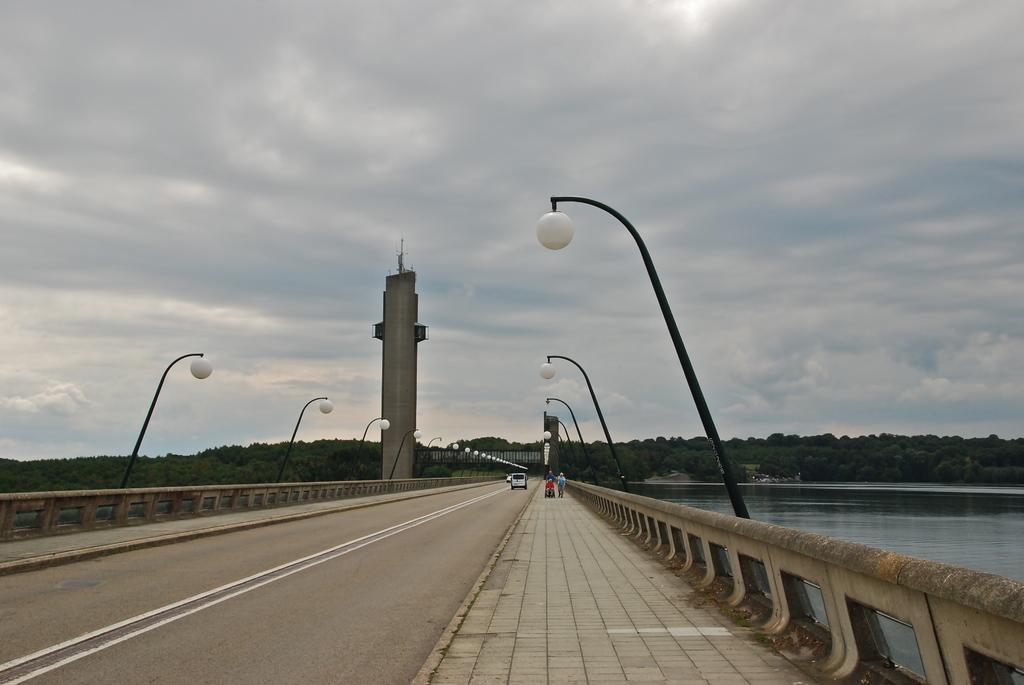In one or two sentences, can you explain what this image depicts? Here we can see a bridge and on it there are few vehicle on the road and on the footpath there are few people standing. In the background there are light poles,trees,water,an object,poles and clouds in the sky 